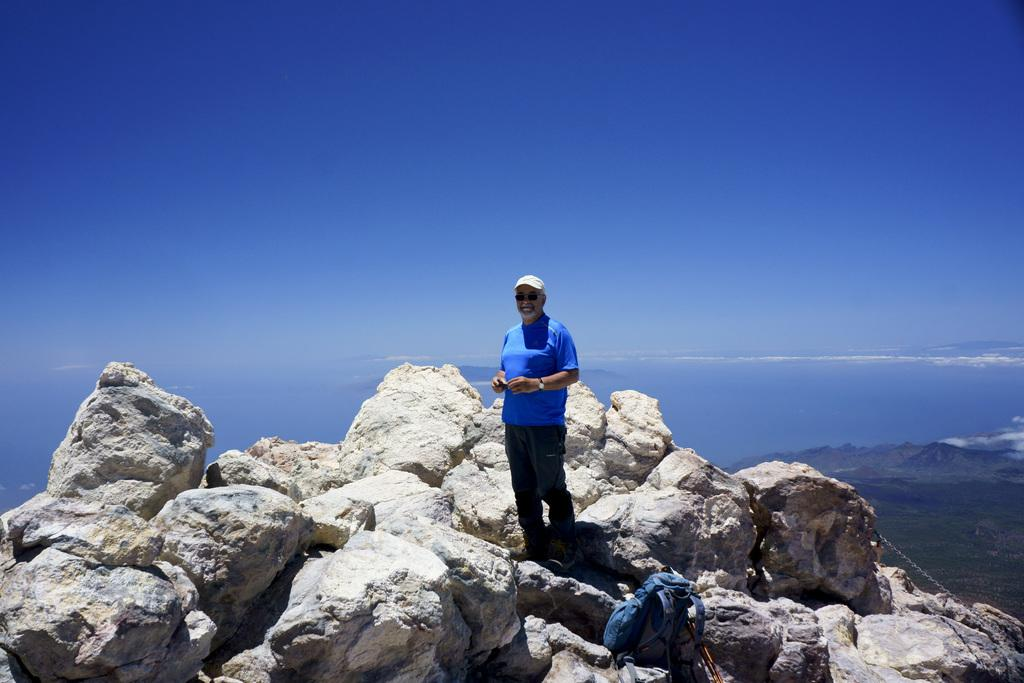Who is present in the image? There is a man in the picture. What is the man wearing? The man is wearing a blue shirt and black pants. What is the man standing on? The man is standing on rocks. What can be seen in the background of the image? There are mountains in the background. How is the sky in the image? The sky is clear. What type of impulse can be seen affecting the mountains in the image? There is no impulse affecting the mountains in the image; they are stationary. How does the harmony between the man and the mountains contribute to the overall aesthetic of the image? The image does not depict any harmony between the man and the mountains; it simply shows a man standing on rocks with mountains in the background. 